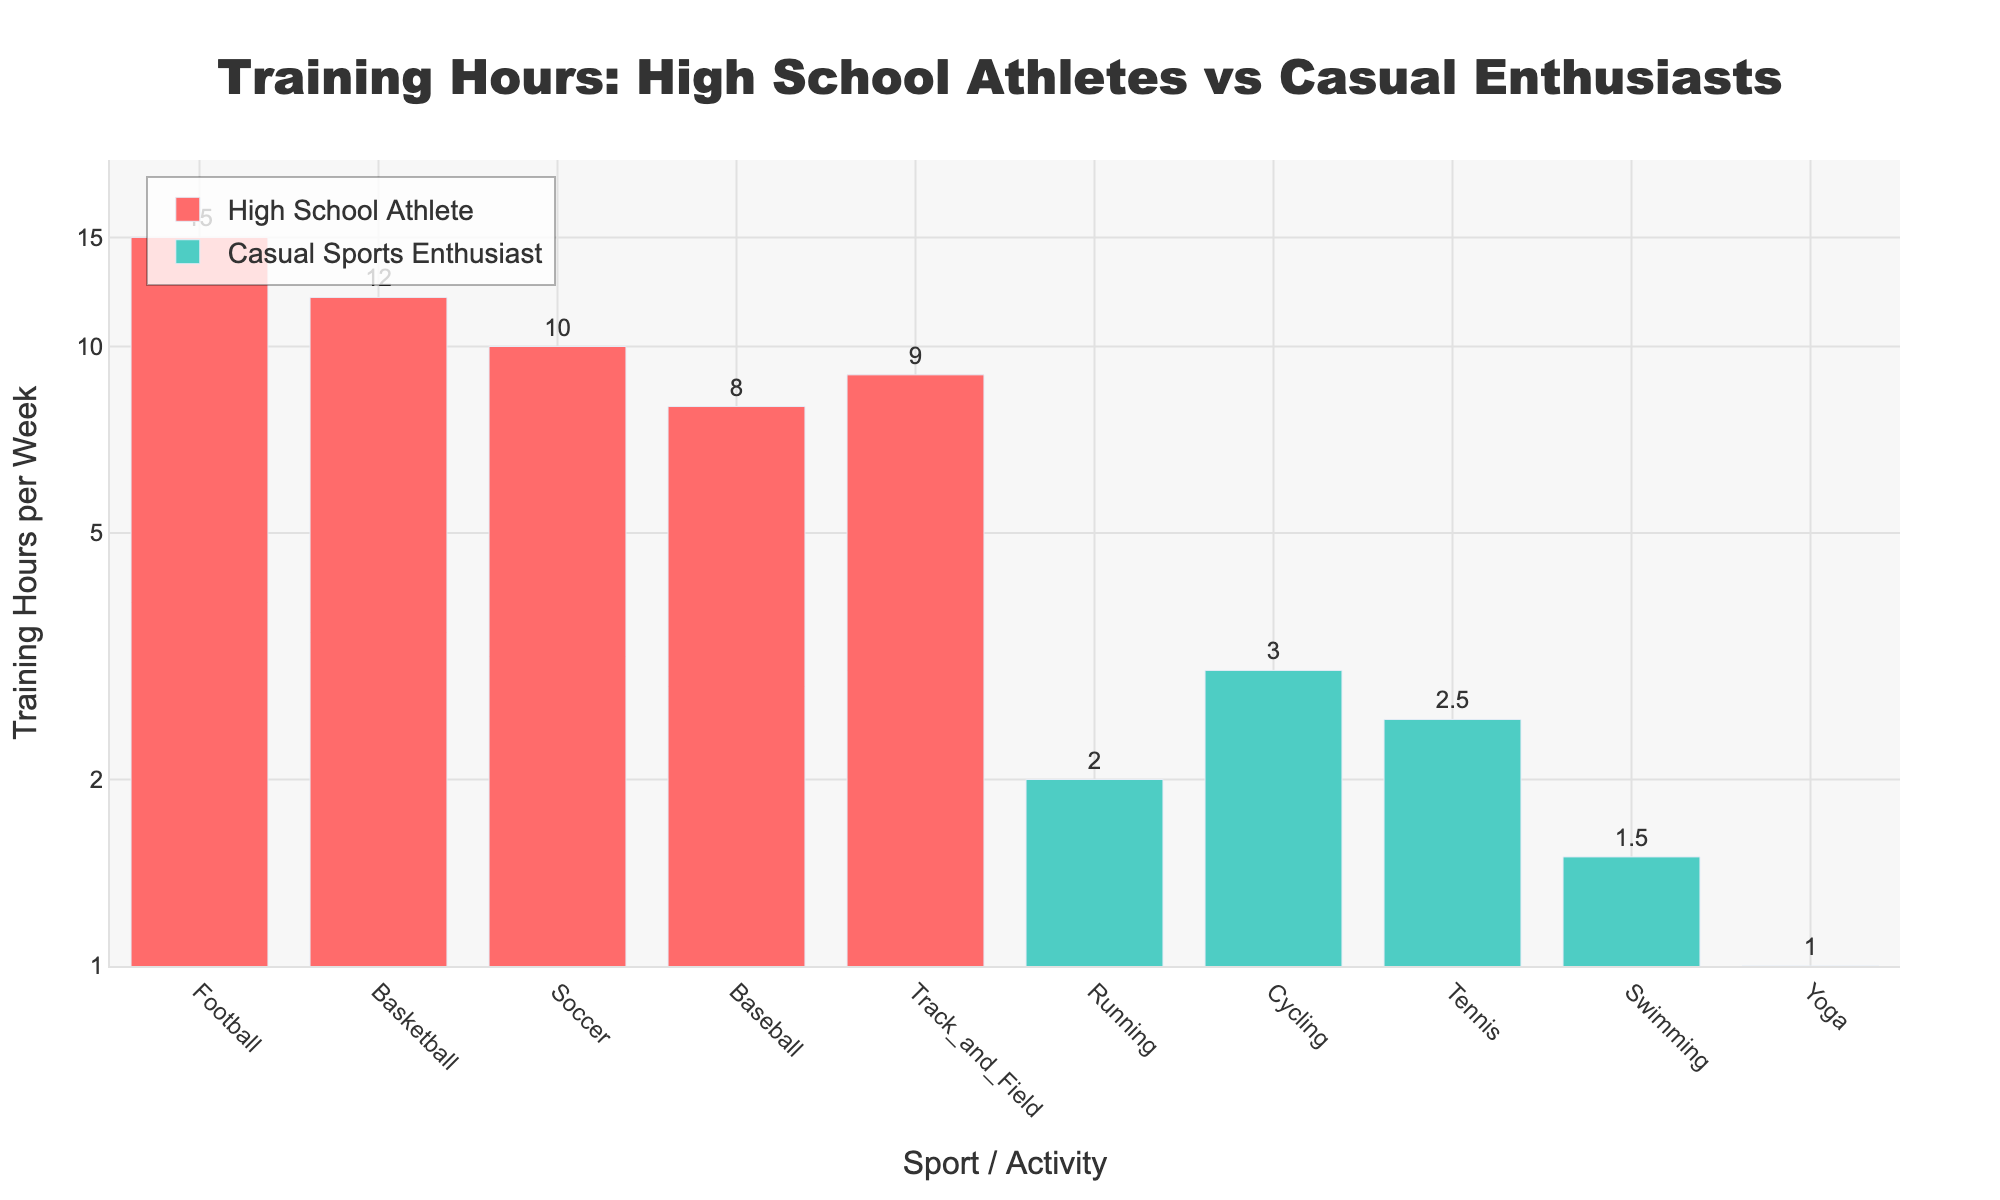What's the title of the figure? The title of the figure is displayed at the top and reads "Training Hours: High School Athletes vs Casual Enthusiasts."
Answer: Training Hours: High School Athletes vs Casual Enthusiasts What is the y-axis label? The y-axis label is written along the vertical axis and it reads "Training Hours per Week."
Answer: Training Hours per Week Which group trains the most hours in a week for a single sport or activity? By looking at the figure, the Football bar for High School Athletes is the highest, indicating 15 training hours per week.
Answer: High School Athletes, Football Are there any activities where casual sports enthusiasts train more hours than high school athletes? By examining the heights of the bars, high school athletes train more hours in every sport listed as compared to the casual sports enthusiasts.
Answer: No What's the difference in training hours between high school football players and casual runners? The figure shows that high school football players train 15 hours per week, while casual runners train 2 hours per week. The difference is 15 - 2 = 13 hours.
Answer: 13 hours Which sports or activities have the highest and lowest training hours for high school athletes? The highest training hours for high school athletes are in Football with 15 hours, and the lowest are in Baseball with 8 hours.
Answer: Football (highest), Baseball (lowest) How many more hours per week do high school basketball players train compared to casual swimmers? High school basketball players train 12 hours per week, while casual swimmers train 1.5 hours per week. The difference is 12 - 1.5 = 10.5 hours.
Answer: 10.5 hours Which category in the figure has more data points, and how many? Counting the bars for each category, High School Athletes have 5 data points, while Casual Sports Enthusiasts have 5 as well.
Answer: Both have 5 What is the average training hours per week for High School Athletes across all sports? Adding the training hours for high school athletes: 15 + 12 + 10 + 8 + 9 = 54. Dividing this by the number of sports (5) gives 54 / 5 = 10.8 hours per week on average.
Answer: 10.8 hours per week Are there any activities where the training hours for high school athletes and casual enthusiasts differ by a factor of 10? The y-axis on a log scale can help identify this. Casual sports enthusiasts with 1-hour training (Yoga) compared with high school athletes training 10 hours (Soccer) show this 10x difference. No other pairs match this ratio exactly.
Answer: Yes 